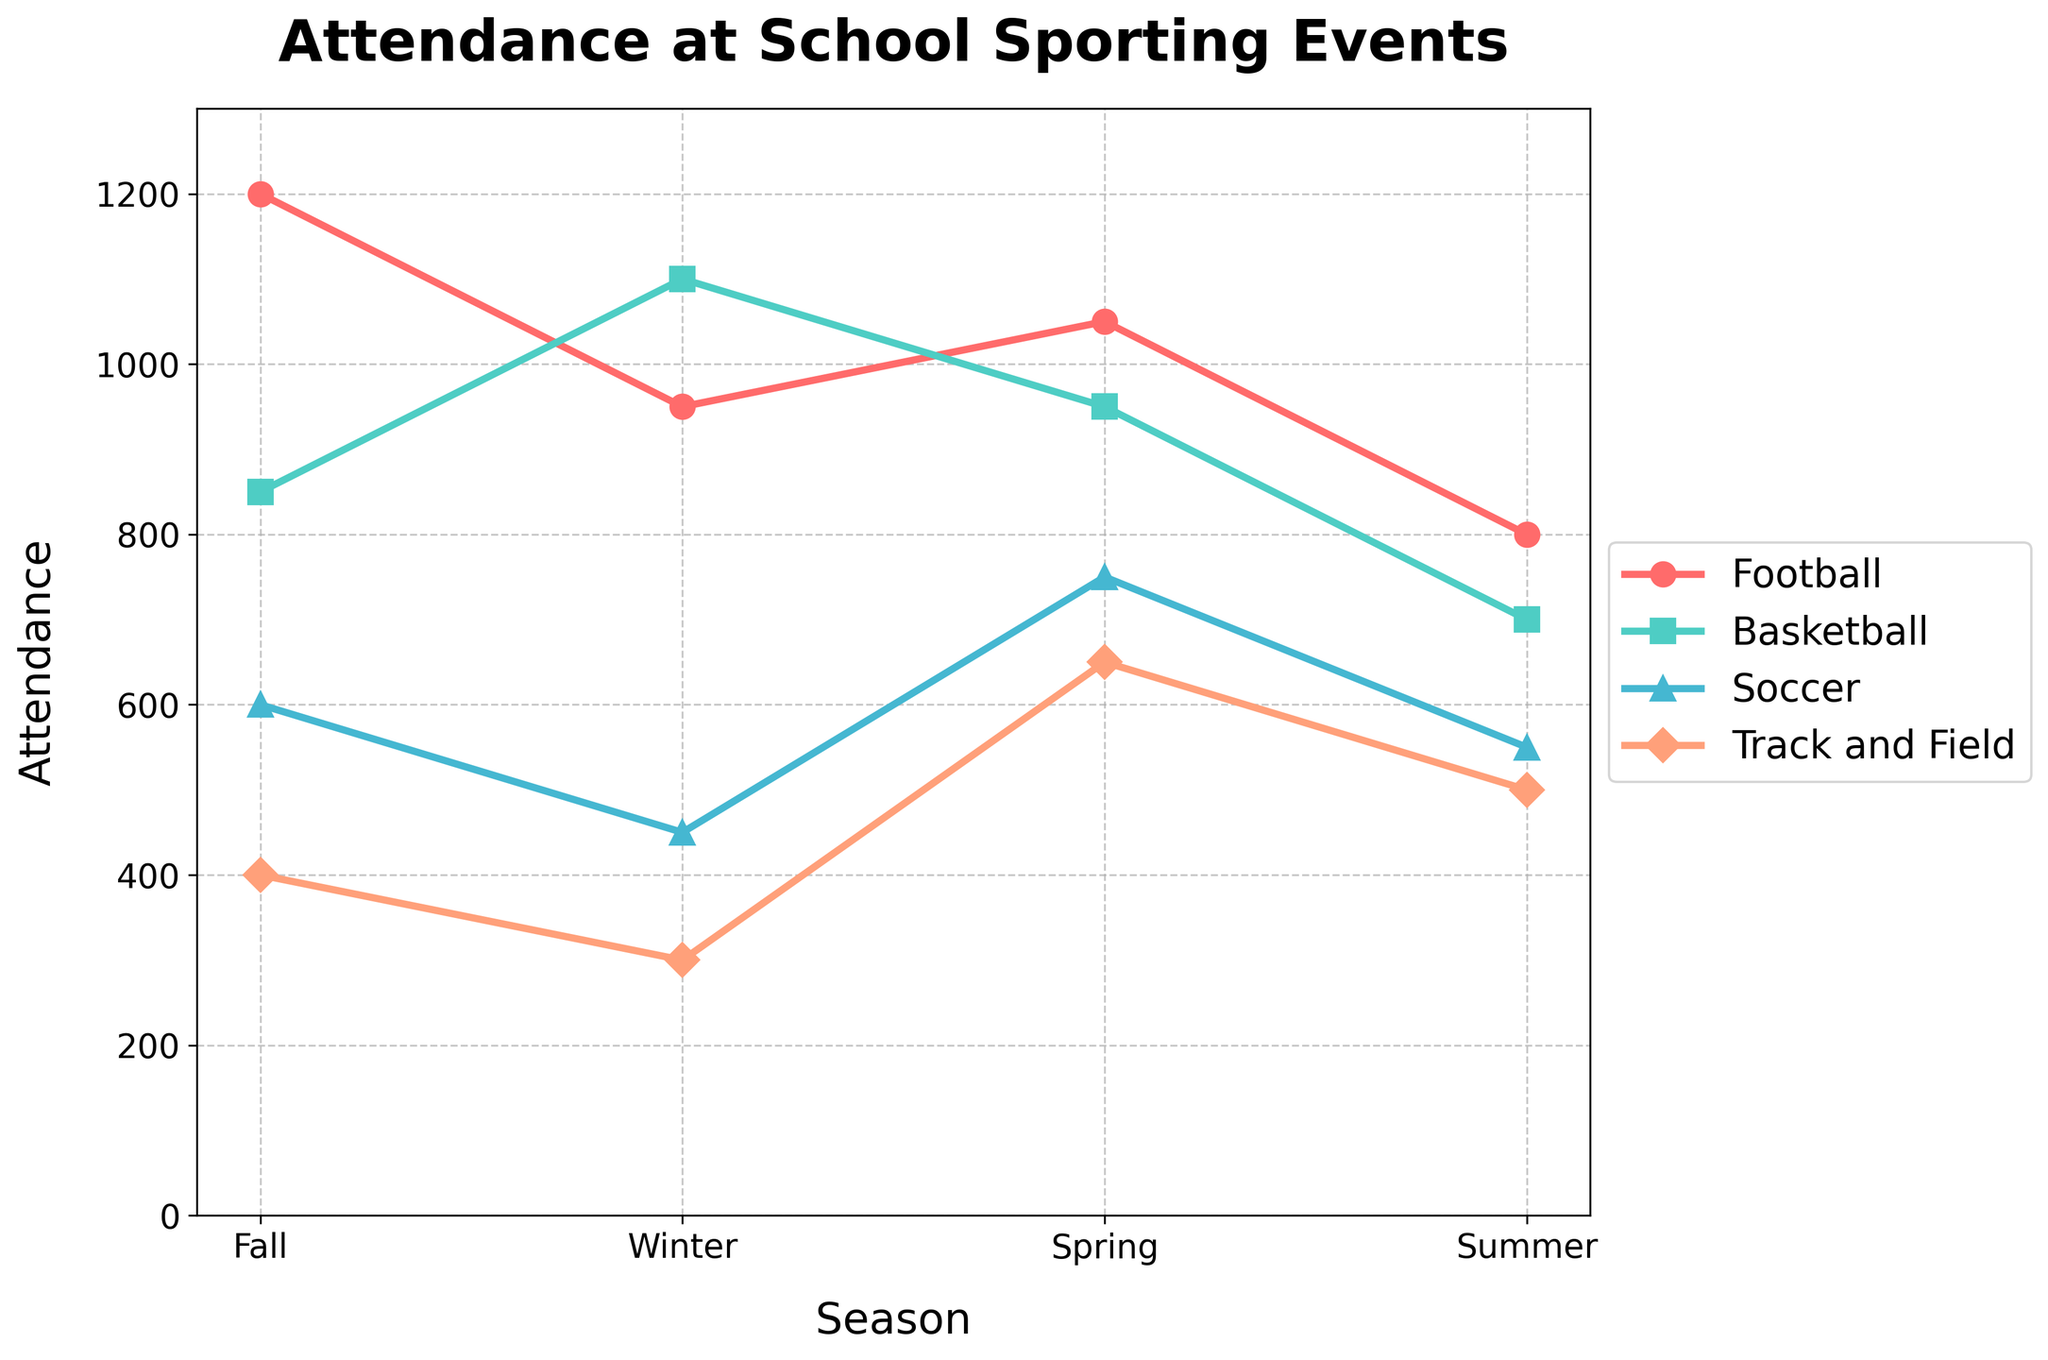Which season had the highest attendance for Basketball? To find the highest attendance for Basketball, look at the heights of the lines marked for Basketball across all seasons. The highest point is in Winter.
Answer: Winter During which season does Soccer have the lowest attendance? Identify the lowest point in the Soccer line across all seasons. The lowest attendance is in Winter.
Answer: Winter Which sport had the highest attendance in Spring? Compare the heights of the lines for all sports in Spring. Football had the highest attendance.
Answer: Football What's the average attendance for Track and Field across all seasons? To find the average: sum the attendance for all seasons (400 + 300 + 650 + 500) = 1850. Then divide by 4 (the number of seasons). 1850 / 4 = 462.5.
Answer: 462.5 Is the attendance for Football higher in Fall or Spring? Compare the heights of the Football line in Fall and Spring. Fall has an attendance of 1200 and Spring has 1050. Fall is higher.
Answer: Fall Which season and sport have the most similar attendances to each other? Look for data points that are close in value. Basketball in Spring (950) and Football in Spring (1050) are the closest.
Answer: Spring, Basketball and Football If we sum up the attendance of Football and Soccer in Fall, how much do we get? Add the attendance of Football (1200) and Soccer (600) in Fall. 1200 + 600 = 1800.
Answer: 1800 What is the difference in Basketball attendance between Fall and Winter? Subtract the attendance of Basketball in Fall from Winter: 1100 - 850 = 250.
Answer: 250 